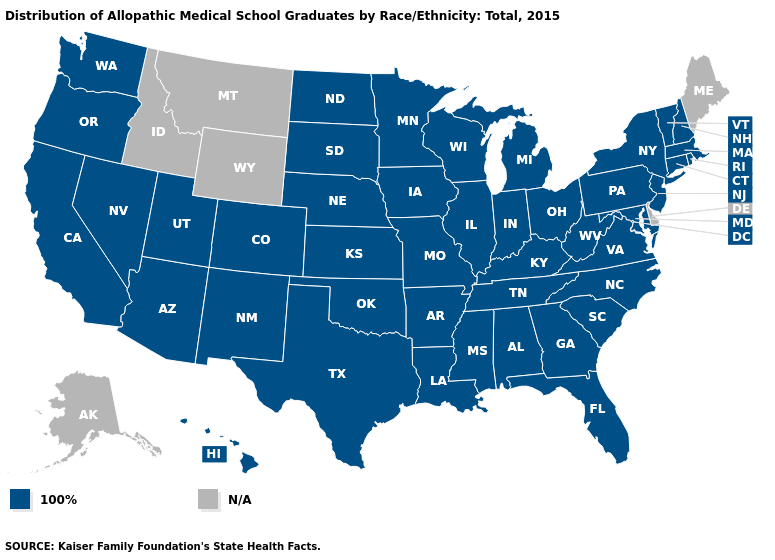What is the value of Idaho?
Answer briefly. N/A. Which states have the lowest value in the USA?
Short answer required. Alabama, Arizona, Arkansas, California, Colorado, Connecticut, Florida, Georgia, Hawaii, Illinois, Indiana, Iowa, Kansas, Kentucky, Louisiana, Maryland, Massachusetts, Michigan, Minnesota, Mississippi, Missouri, Nebraska, Nevada, New Hampshire, New Jersey, New Mexico, New York, North Carolina, North Dakota, Ohio, Oklahoma, Oregon, Pennsylvania, Rhode Island, South Carolina, South Dakota, Tennessee, Texas, Utah, Vermont, Virginia, Washington, West Virginia, Wisconsin. What is the value of Rhode Island?
Answer briefly. 100%. What is the lowest value in the Northeast?
Short answer required. 100%. Which states hav the highest value in the Northeast?
Short answer required. Connecticut, Massachusetts, New Hampshire, New Jersey, New York, Pennsylvania, Rhode Island, Vermont. Name the states that have a value in the range 100%?
Keep it brief. Alabama, Arizona, Arkansas, California, Colorado, Connecticut, Florida, Georgia, Hawaii, Illinois, Indiana, Iowa, Kansas, Kentucky, Louisiana, Maryland, Massachusetts, Michigan, Minnesota, Mississippi, Missouri, Nebraska, Nevada, New Hampshire, New Jersey, New Mexico, New York, North Carolina, North Dakota, Ohio, Oklahoma, Oregon, Pennsylvania, Rhode Island, South Carolina, South Dakota, Tennessee, Texas, Utah, Vermont, Virginia, Washington, West Virginia, Wisconsin. Name the states that have a value in the range N/A?
Give a very brief answer. Alaska, Delaware, Idaho, Maine, Montana, Wyoming. Name the states that have a value in the range N/A?
Be succinct. Alaska, Delaware, Idaho, Maine, Montana, Wyoming. Name the states that have a value in the range 100%?
Give a very brief answer. Alabama, Arizona, Arkansas, California, Colorado, Connecticut, Florida, Georgia, Hawaii, Illinois, Indiana, Iowa, Kansas, Kentucky, Louisiana, Maryland, Massachusetts, Michigan, Minnesota, Mississippi, Missouri, Nebraska, Nevada, New Hampshire, New Jersey, New Mexico, New York, North Carolina, North Dakota, Ohio, Oklahoma, Oregon, Pennsylvania, Rhode Island, South Carolina, South Dakota, Tennessee, Texas, Utah, Vermont, Virginia, Washington, West Virginia, Wisconsin. What is the highest value in the USA?
Write a very short answer. 100%. Does the map have missing data?
Write a very short answer. Yes. What is the highest value in states that border North Dakota?
Write a very short answer. 100%. 